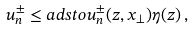Convert formula to latex. <formula><loc_0><loc_0><loc_500><loc_500>u ^ { \pm } _ { n } \leq a d s t o u ^ { \pm } _ { n } ( z , x _ { \bot } ) \eta ( z ) \, ,</formula> 